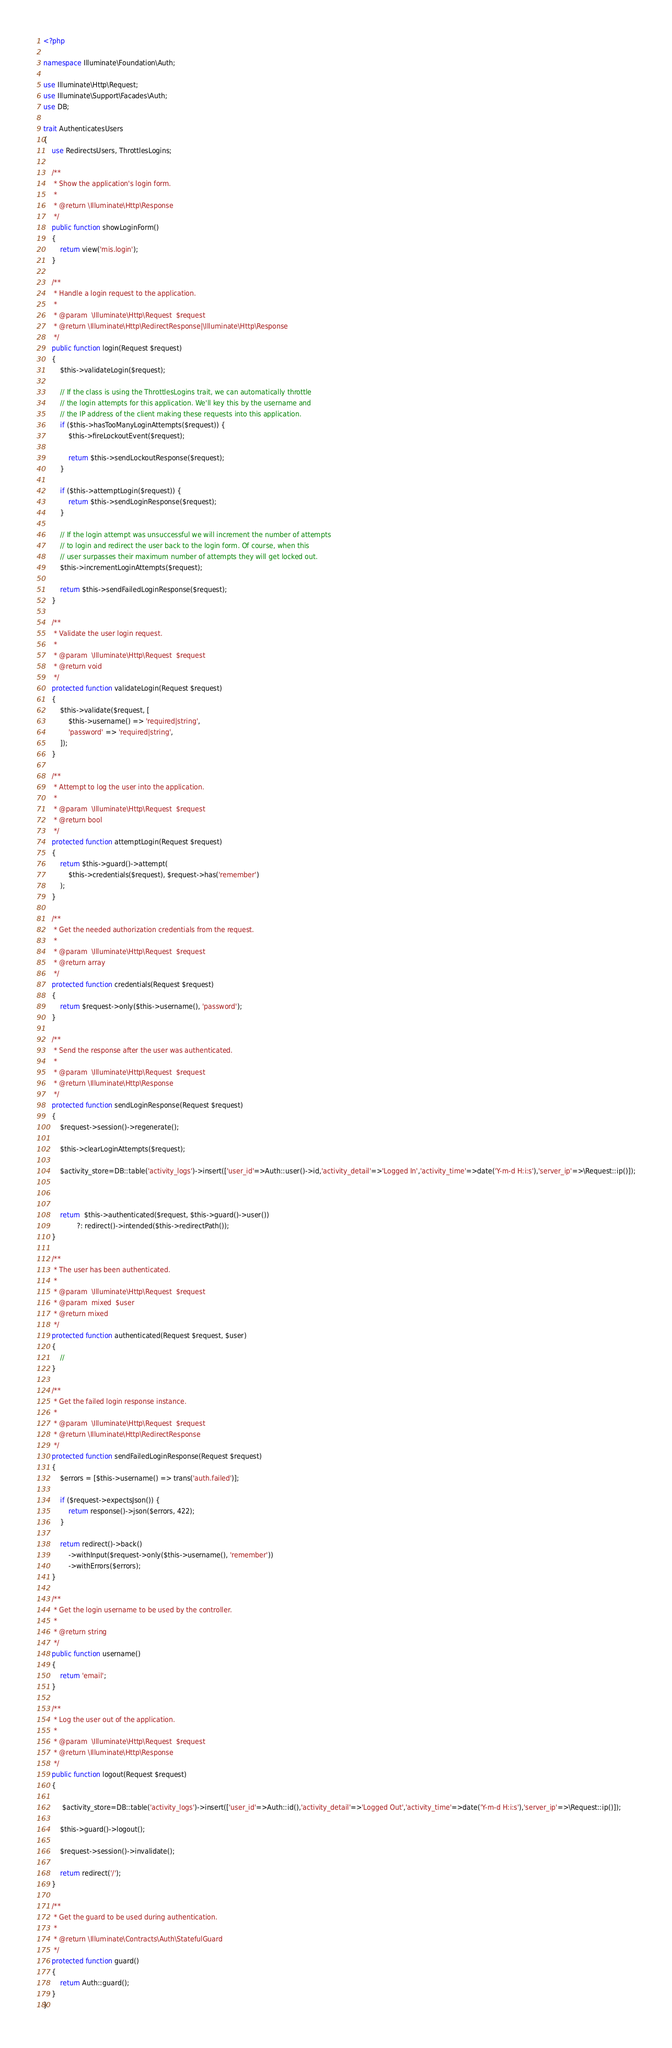Convert code to text. <code><loc_0><loc_0><loc_500><loc_500><_PHP_><?php

namespace Illuminate\Foundation\Auth;

use Illuminate\Http\Request;
use Illuminate\Support\Facades\Auth;
use DB;

trait AuthenticatesUsers
{
    use RedirectsUsers, ThrottlesLogins;

    /**
     * Show the application's login form.
     *
     * @return \Illuminate\Http\Response
     */
    public function showLoginForm()
    {
        return view('mis.login');
    }

    /**
     * Handle a login request to the application.
     *
     * @param  \Illuminate\Http\Request  $request
     * @return \Illuminate\Http\RedirectResponse|\Illuminate\Http\Response
     */
    public function login(Request $request)
    {
        $this->validateLogin($request);

        // If the class is using the ThrottlesLogins trait, we can automatically throttle
        // the login attempts for this application. We'll key this by the username and
        // the IP address of the client making these requests into this application.
        if ($this->hasTooManyLoginAttempts($request)) {
            $this->fireLockoutEvent($request);

            return $this->sendLockoutResponse($request);
        }

        if ($this->attemptLogin($request)) {
            return $this->sendLoginResponse($request);
        }

        // If the login attempt was unsuccessful we will increment the number of attempts
        // to login and redirect the user back to the login form. Of course, when this
        // user surpasses their maximum number of attempts they will get locked out.
        $this->incrementLoginAttempts($request);

        return $this->sendFailedLoginResponse($request);
    }

    /**
     * Validate the user login request.
     *
     * @param  \Illuminate\Http\Request  $request
     * @return void
     */
    protected function validateLogin(Request $request)
    {
        $this->validate($request, [
            $this->username() => 'required|string',
            'password' => 'required|string',
        ]);
    }

    /**
     * Attempt to log the user into the application.
     *
     * @param  \Illuminate\Http\Request  $request
     * @return bool
     */
    protected function attemptLogin(Request $request)
    {
        return $this->guard()->attempt(
            $this->credentials($request), $request->has('remember')
        );
    }

    /**
     * Get the needed authorization credentials from the request.
     *
     * @param  \Illuminate\Http\Request  $request
     * @return array
     */
    protected function credentials(Request $request)
    {
        return $request->only($this->username(), 'password');
    }

    /**
     * Send the response after the user was authenticated.
     *
     * @param  \Illuminate\Http\Request  $request
     * @return \Illuminate\Http\Response
     */
    protected function sendLoginResponse(Request $request)
    {
        $request->session()->regenerate();

        $this->clearLoginAttempts($request);

        $activity_store=DB::table('activity_logs')->insert(['user_id'=>Auth::user()->id,'activity_detail'=>'Logged In','activity_time'=>date('Y-m-d H:i:s'),'server_ip'=>\Request::ip()]);

             

        return  $this->authenticated($request, $this->guard()->user())
                ?: redirect()->intended($this->redirectPath());
    }

    /**
     * The user has been authenticated.
     *
     * @param  \Illuminate\Http\Request  $request
     * @param  mixed  $user
     * @return mixed
     */
    protected function authenticated(Request $request, $user)
    {
        //
    }

    /**
     * Get the failed login response instance.
     *
     * @param  \Illuminate\Http\Request  $request
     * @return \Illuminate\Http\RedirectResponse
     */
    protected function sendFailedLoginResponse(Request $request)
    {
        $errors = [$this->username() => trans('auth.failed')];

        if ($request->expectsJson()) {
            return response()->json($errors, 422);
        }

        return redirect()->back()
            ->withInput($request->only($this->username(), 'remember'))
            ->withErrors($errors);
    }

    /**
     * Get the login username to be used by the controller.
     *
     * @return string
     */
    public function username()
    {
        return 'email';
    }

    /**
     * Log the user out of the application.
     *
     * @param  \Illuminate\Http\Request  $request
     * @return \Illuminate\Http\Response
     */
    public function logout(Request $request)
    {
       
         $activity_store=DB::table('activity_logs')->insert(['user_id'=>Auth::id(),'activity_detail'=>'Logged Out','activity_time'=>date('Y-m-d H:i:s'),'server_ip'=>\Request::ip()]);

        $this->guard()->logout();

        $request->session()->invalidate();

        return redirect('/');
    }

    /**
     * Get the guard to be used during authentication.
     *
     * @return \Illuminate\Contracts\Auth\StatefulGuard
     */
    protected function guard()
    {
        return Auth::guard();
    }
}
</code> 